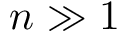<formula> <loc_0><loc_0><loc_500><loc_500>n \gg 1</formula> 